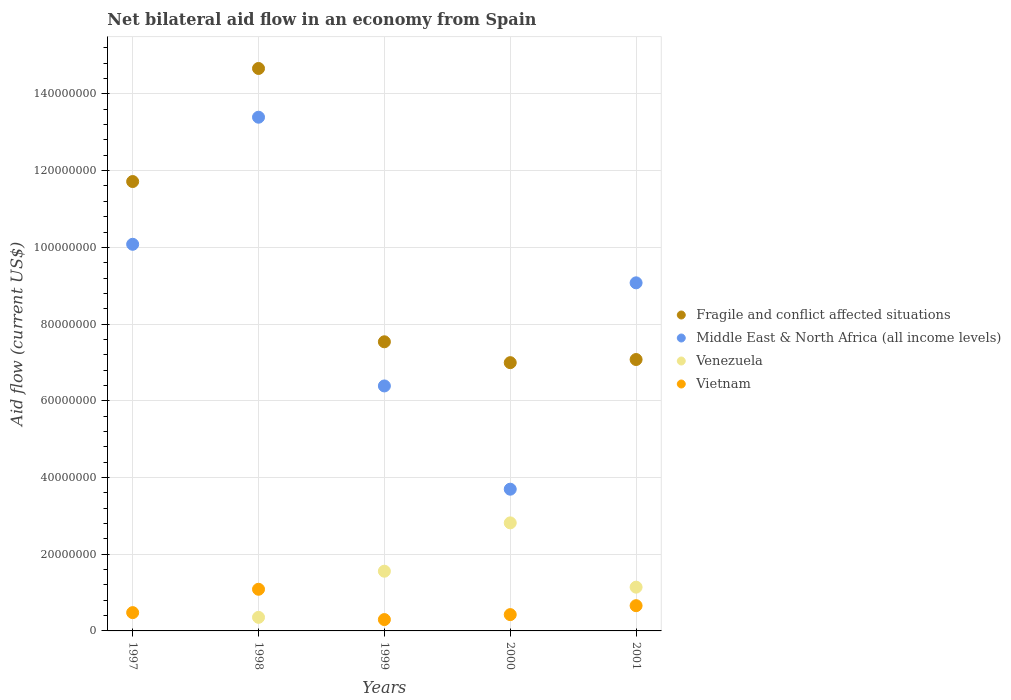How many different coloured dotlines are there?
Offer a very short reply. 4. Is the number of dotlines equal to the number of legend labels?
Provide a short and direct response. No. What is the net bilateral aid flow in Middle East & North Africa (all income levels) in 2000?
Your answer should be very brief. 3.70e+07. Across all years, what is the maximum net bilateral aid flow in Fragile and conflict affected situations?
Your answer should be compact. 1.47e+08. What is the total net bilateral aid flow in Middle East & North Africa (all income levels) in the graph?
Give a very brief answer. 4.26e+08. What is the difference between the net bilateral aid flow in Middle East & North Africa (all income levels) in 1999 and that in 2001?
Your answer should be compact. -2.69e+07. What is the difference between the net bilateral aid flow in Fragile and conflict affected situations in 1998 and the net bilateral aid flow in Vietnam in 2001?
Your answer should be compact. 1.40e+08. What is the average net bilateral aid flow in Vietnam per year?
Give a very brief answer. 5.88e+06. In the year 1999, what is the difference between the net bilateral aid flow in Vietnam and net bilateral aid flow in Fragile and conflict affected situations?
Offer a very short reply. -7.24e+07. What is the ratio of the net bilateral aid flow in Venezuela in 1999 to that in 2001?
Your answer should be compact. 1.36. Is the difference between the net bilateral aid flow in Vietnam in 1998 and 2000 greater than the difference between the net bilateral aid flow in Fragile and conflict affected situations in 1998 and 2000?
Keep it short and to the point. No. What is the difference between the highest and the second highest net bilateral aid flow in Vietnam?
Provide a succinct answer. 4.28e+06. What is the difference between the highest and the lowest net bilateral aid flow in Venezuela?
Your answer should be very brief. 2.82e+07. Is the sum of the net bilateral aid flow in Venezuela in 1999 and 2001 greater than the maximum net bilateral aid flow in Vietnam across all years?
Your response must be concise. Yes. Is the net bilateral aid flow in Venezuela strictly greater than the net bilateral aid flow in Vietnam over the years?
Provide a short and direct response. No. How many dotlines are there?
Provide a short and direct response. 4. How many years are there in the graph?
Make the answer very short. 5. What is the difference between two consecutive major ticks on the Y-axis?
Provide a succinct answer. 2.00e+07. Does the graph contain any zero values?
Make the answer very short. Yes. How many legend labels are there?
Your answer should be compact. 4. How are the legend labels stacked?
Offer a terse response. Vertical. What is the title of the graph?
Offer a very short reply. Net bilateral aid flow in an economy from Spain. What is the label or title of the X-axis?
Keep it short and to the point. Years. What is the label or title of the Y-axis?
Keep it short and to the point. Aid flow (current US$). What is the Aid flow (current US$) of Fragile and conflict affected situations in 1997?
Provide a succinct answer. 1.17e+08. What is the Aid flow (current US$) in Middle East & North Africa (all income levels) in 1997?
Your response must be concise. 1.01e+08. What is the Aid flow (current US$) of Venezuela in 1997?
Give a very brief answer. 0. What is the Aid flow (current US$) in Vietnam in 1997?
Provide a short and direct response. 4.77e+06. What is the Aid flow (current US$) in Fragile and conflict affected situations in 1998?
Provide a succinct answer. 1.47e+08. What is the Aid flow (current US$) in Middle East & North Africa (all income levels) in 1998?
Your answer should be compact. 1.34e+08. What is the Aid flow (current US$) of Venezuela in 1998?
Offer a very short reply. 3.54e+06. What is the Aid flow (current US$) of Vietnam in 1998?
Your answer should be compact. 1.09e+07. What is the Aid flow (current US$) in Fragile and conflict affected situations in 1999?
Your answer should be very brief. 7.54e+07. What is the Aid flow (current US$) in Middle East & North Africa (all income levels) in 1999?
Make the answer very short. 6.39e+07. What is the Aid flow (current US$) of Venezuela in 1999?
Give a very brief answer. 1.56e+07. What is the Aid flow (current US$) of Vietnam in 1999?
Offer a terse response. 2.96e+06. What is the Aid flow (current US$) of Fragile and conflict affected situations in 2000?
Offer a very short reply. 6.99e+07. What is the Aid flow (current US$) of Middle East & North Africa (all income levels) in 2000?
Ensure brevity in your answer.  3.70e+07. What is the Aid flow (current US$) of Venezuela in 2000?
Provide a short and direct response. 2.82e+07. What is the Aid flow (current US$) in Vietnam in 2000?
Give a very brief answer. 4.25e+06. What is the Aid flow (current US$) of Fragile and conflict affected situations in 2001?
Your answer should be very brief. 7.08e+07. What is the Aid flow (current US$) in Middle East & North Africa (all income levels) in 2001?
Your answer should be very brief. 9.08e+07. What is the Aid flow (current US$) of Venezuela in 2001?
Ensure brevity in your answer.  1.14e+07. What is the Aid flow (current US$) in Vietnam in 2001?
Your response must be concise. 6.58e+06. Across all years, what is the maximum Aid flow (current US$) of Fragile and conflict affected situations?
Keep it short and to the point. 1.47e+08. Across all years, what is the maximum Aid flow (current US$) of Middle East & North Africa (all income levels)?
Make the answer very short. 1.34e+08. Across all years, what is the maximum Aid flow (current US$) in Venezuela?
Ensure brevity in your answer.  2.82e+07. Across all years, what is the maximum Aid flow (current US$) of Vietnam?
Give a very brief answer. 1.09e+07. Across all years, what is the minimum Aid flow (current US$) in Fragile and conflict affected situations?
Provide a succinct answer. 6.99e+07. Across all years, what is the minimum Aid flow (current US$) in Middle East & North Africa (all income levels)?
Your response must be concise. 3.70e+07. Across all years, what is the minimum Aid flow (current US$) in Venezuela?
Ensure brevity in your answer.  0. Across all years, what is the minimum Aid flow (current US$) in Vietnam?
Offer a terse response. 2.96e+06. What is the total Aid flow (current US$) in Fragile and conflict affected situations in the graph?
Your response must be concise. 4.80e+08. What is the total Aid flow (current US$) of Middle East & North Africa (all income levels) in the graph?
Your response must be concise. 4.26e+08. What is the total Aid flow (current US$) of Venezuela in the graph?
Ensure brevity in your answer.  5.87e+07. What is the total Aid flow (current US$) of Vietnam in the graph?
Provide a short and direct response. 2.94e+07. What is the difference between the Aid flow (current US$) of Fragile and conflict affected situations in 1997 and that in 1998?
Provide a short and direct response. -2.95e+07. What is the difference between the Aid flow (current US$) of Middle East & North Africa (all income levels) in 1997 and that in 1998?
Offer a very short reply. -3.31e+07. What is the difference between the Aid flow (current US$) of Vietnam in 1997 and that in 1998?
Your answer should be compact. -6.09e+06. What is the difference between the Aid flow (current US$) of Fragile and conflict affected situations in 1997 and that in 1999?
Offer a very short reply. 4.18e+07. What is the difference between the Aid flow (current US$) in Middle East & North Africa (all income levels) in 1997 and that in 1999?
Provide a short and direct response. 3.69e+07. What is the difference between the Aid flow (current US$) of Vietnam in 1997 and that in 1999?
Offer a very short reply. 1.81e+06. What is the difference between the Aid flow (current US$) in Fragile and conflict affected situations in 1997 and that in 2000?
Your answer should be very brief. 4.72e+07. What is the difference between the Aid flow (current US$) in Middle East & North Africa (all income levels) in 1997 and that in 2000?
Provide a succinct answer. 6.38e+07. What is the difference between the Aid flow (current US$) in Vietnam in 1997 and that in 2000?
Provide a short and direct response. 5.20e+05. What is the difference between the Aid flow (current US$) of Fragile and conflict affected situations in 1997 and that in 2001?
Offer a very short reply. 4.64e+07. What is the difference between the Aid flow (current US$) of Middle East & North Africa (all income levels) in 1997 and that in 2001?
Your answer should be compact. 1.00e+07. What is the difference between the Aid flow (current US$) in Vietnam in 1997 and that in 2001?
Offer a very short reply. -1.81e+06. What is the difference between the Aid flow (current US$) in Fragile and conflict affected situations in 1998 and that in 1999?
Your response must be concise. 7.13e+07. What is the difference between the Aid flow (current US$) of Middle East & North Africa (all income levels) in 1998 and that in 1999?
Your response must be concise. 7.01e+07. What is the difference between the Aid flow (current US$) in Venezuela in 1998 and that in 1999?
Keep it short and to the point. -1.20e+07. What is the difference between the Aid flow (current US$) of Vietnam in 1998 and that in 1999?
Your response must be concise. 7.90e+06. What is the difference between the Aid flow (current US$) of Fragile and conflict affected situations in 1998 and that in 2000?
Keep it short and to the point. 7.67e+07. What is the difference between the Aid flow (current US$) of Middle East & North Africa (all income levels) in 1998 and that in 2000?
Provide a short and direct response. 9.70e+07. What is the difference between the Aid flow (current US$) in Venezuela in 1998 and that in 2000?
Keep it short and to the point. -2.46e+07. What is the difference between the Aid flow (current US$) of Vietnam in 1998 and that in 2000?
Ensure brevity in your answer.  6.61e+06. What is the difference between the Aid flow (current US$) of Fragile and conflict affected situations in 1998 and that in 2001?
Offer a very short reply. 7.59e+07. What is the difference between the Aid flow (current US$) of Middle East & North Africa (all income levels) in 1998 and that in 2001?
Keep it short and to the point. 4.32e+07. What is the difference between the Aid flow (current US$) in Venezuela in 1998 and that in 2001?
Offer a terse response. -7.87e+06. What is the difference between the Aid flow (current US$) in Vietnam in 1998 and that in 2001?
Give a very brief answer. 4.28e+06. What is the difference between the Aid flow (current US$) in Fragile and conflict affected situations in 1999 and that in 2000?
Offer a very short reply. 5.44e+06. What is the difference between the Aid flow (current US$) of Middle East & North Africa (all income levels) in 1999 and that in 2000?
Your answer should be compact. 2.69e+07. What is the difference between the Aid flow (current US$) of Venezuela in 1999 and that in 2000?
Offer a terse response. -1.26e+07. What is the difference between the Aid flow (current US$) in Vietnam in 1999 and that in 2000?
Offer a very short reply. -1.29e+06. What is the difference between the Aid flow (current US$) in Fragile and conflict affected situations in 1999 and that in 2001?
Offer a very short reply. 4.62e+06. What is the difference between the Aid flow (current US$) of Middle East & North Africa (all income levels) in 1999 and that in 2001?
Provide a succinct answer. -2.69e+07. What is the difference between the Aid flow (current US$) in Venezuela in 1999 and that in 2001?
Your response must be concise. 4.16e+06. What is the difference between the Aid flow (current US$) in Vietnam in 1999 and that in 2001?
Keep it short and to the point. -3.62e+06. What is the difference between the Aid flow (current US$) of Fragile and conflict affected situations in 2000 and that in 2001?
Offer a terse response. -8.20e+05. What is the difference between the Aid flow (current US$) in Middle East & North Africa (all income levels) in 2000 and that in 2001?
Ensure brevity in your answer.  -5.38e+07. What is the difference between the Aid flow (current US$) in Venezuela in 2000 and that in 2001?
Your answer should be compact. 1.68e+07. What is the difference between the Aid flow (current US$) in Vietnam in 2000 and that in 2001?
Your answer should be very brief. -2.33e+06. What is the difference between the Aid flow (current US$) of Fragile and conflict affected situations in 1997 and the Aid flow (current US$) of Middle East & North Africa (all income levels) in 1998?
Your response must be concise. -1.68e+07. What is the difference between the Aid flow (current US$) of Fragile and conflict affected situations in 1997 and the Aid flow (current US$) of Venezuela in 1998?
Provide a succinct answer. 1.14e+08. What is the difference between the Aid flow (current US$) of Fragile and conflict affected situations in 1997 and the Aid flow (current US$) of Vietnam in 1998?
Make the answer very short. 1.06e+08. What is the difference between the Aid flow (current US$) of Middle East & North Africa (all income levels) in 1997 and the Aid flow (current US$) of Venezuela in 1998?
Offer a terse response. 9.73e+07. What is the difference between the Aid flow (current US$) of Middle East & North Africa (all income levels) in 1997 and the Aid flow (current US$) of Vietnam in 1998?
Provide a short and direct response. 8.99e+07. What is the difference between the Aid flow (current US$) of Fragile and conflict affected situations in 1997 and the Aid flow (current US$) of Middle East & North Africa (all income levels) in 1999?
Offer a terse response. 5.33e+07. What is the difference between the Aid flow (current US$) in Fragile and conflict affected situations in 1997 and the Aid flow (current US$) in Venezuela in 1999?
Give a very brief answer. 1.02e+08. What is the difference between the Aid flow (current US$) of Fragile and conflict affected situations in 1997 and the Aid flow (current US$) of Vietnam in 1999?
Your answer should be very brief. 1.14e+08. What is the difference between the Aid flow (current US$) in Middle East & North Africa (all income levels) in 1997 and the Aid flow (current US$) in Venezuela in 1999?
Make the answer very short. 8.52e+07. What is the difference between the Aid flow (current US$) in Middle East & North Africa (all income levels) in 1997 and the Aid flow (current US$) in Vietnam in 1999?
Offer a terse response. 9.78e+07. What is the difference between the Aid flow (current US$) of Fragile and conflict affected situations in 1997 and the Aid flow (current US$) of Middle East & North Africa (all income levels) in 2000?
Give a very brief answer. 8.02e+07. What is the difference between the Aid flow (current US$) in Fragile and conflict affected situations in 1997 and the Aid flow (current US$) in Venezuela in 2000?
Keep it short and to the point. 8.90e+07. What is the difference between the Aid flow (current US$) in Fragile and conflict affected situations in 1997 and the Aid flow (current US$) in Vietnam in 2000?
Your response must be concise. 1.13e+08. What is the difference between the Aid flow (current US$) in Middle East & North Africa (all income levels) in 1997 and the Aid flow (current US$) in Venezuela in 2000?
Offer a terse response. 7.26e+07. What is the difference between the Aid flow (current US$) in Middle East & North Africa (all income levels) in 1997 and the Aid flow (current US$) in Vietnam in 2000?
Ensure brevity in your answer.  9.66e+07. What is the difference between the Aid flow (current US$) in Fragile and conflict affected situations in 1997 and the Aid flow (current US$) in Middle East & North Africa (all income levels) in 2001?
Your answer should be compact. 2.64e+07. What is the difference between the Aid flow (current US$) in Fragile and conflict affected situations in 1997 and the Aid flow (current US$) in Venezuela in 2001?
Offer a terse response. 1.06e+08. What is the difference between the Aid flow (current US$) of Fragile and conflict affected situations in 1997 and the Aid flow (current US$) of Vietnam in 2001?
Your answer should be compact. 1.11e+08. What is the difference between the Aid flow (current US$) in Middle East & North Africa (all income levels) in 1997 and the Aid flow (current US$) in Venezuela in 2001?
Offer a terse response. 8.94e+07. What is the difference between the Aid flow (current US$) in Middle East & North Africa (all income levels) in 1997 and the Aid flow (current US$) in Vietnam in 2001?
Offer a terse response. 9.42e+07. What is the difference between the Aid flow (current US$) of Fragile and conflict affected situations in 1998 and the Aid flow (current US$) of Middle East & North Africa (all income levels) in 1999?
Give a very brief answer. 8.28e+07. What is the difference between the Aid flow (current US$) of Fragile and conflict affected situations in 1998 and the Aid flow (current US$) of Venezuela in 1999?
Provide a short and direct response. 1.31e+08. What is the difference between the Aid flow (current US$) of Fragile and conflict affected situations in 1998 and the Aid flow (current US$) of Vietnam in 1999?
Offer a very short reply. 1.44e+08. What is the difference between the Aid flow (current US$) in Middle East & North Africa (all income levels) in 1998 and the Aid flow (current US$) in Venezuela in 1999?
Your answer should be compact. 1.18e+08. What is the difference between the Aid flow (current US$) of Middle East & North Africa (all income levels) in 1998 and the Aid flow (current US$) of Vietnam in 1999?
Ensure brevity in your answer.  1.31e+08. What is the difference between the Aid flow (current US$) of Venezuela in 1998 and the Aid flow (current US$) of Vietnam in 1999?
Provide a short and direct response. 5.80e+05. What is the difference between the Aid flow (current US$) in Fragile and conflict affected situations in 1998 and the Aid flow (current US$) in Middle East & North Africa (all income levels) in 2000?
Offer a terse response. 1.10e+08. What is the difference between the Aid flow (current US$) of Fragile and conflict affected situations in 1998 and the Aid flow (current US$) of Venezuela in 2000?
Your answer should be compact. 1.18e+08. What is the difference between the Aid flow (current US$) in Fragile and conflict affected situations in 1998 and the Aid flow (current US$) in Vietnam in 2000?
Offer a very short reply. 1.42e+08. What is the difference between the Aid flow (current US$) in Middle East & North Africa (all income levels) in 1998 and the Aid flow (current US$) in Venezuela in 2000?
Ensure brevity in your answer.  1.06e+08. What is the difference between the Aid flow (current US$) in Middle East & North Africa (all income levels) in 1998 and the Aid flow (current US$) in Vietnam in 2000?
Your response must be concise. 1.30e+08. What is the difference between the Aid flow (current US$) in Venezuela in 1998 and the Aid flow (current US$) in Vietnam in 2000?
Your answer should be compact. -7.10e+05. What is the difference between the Aid flow (current US$) of Fragile and conflict affected situations in 1998 and the Aid flow (current US$) of Middle East & North Africa (all income levels) in 2001?
Offer a very short reply. 5.59e+07. What is the difference between the Aid flow (current US$) in Fragile and conflict affected situations in 1998 and the Aid flow (current US$) in Venezuela in 2001?
Give a very brief answer. 1.35e+08. What is the difference between the Aid flow (current US$) of Fragile and conflict affected situations in 1998 and the Aid flow (current US$) of Vietnam in 2001?
Your response must be concise. 1.40e+08. What is the difference between the Aid flow (current US$) of Middle East & North Africa (all income levels) in 1998 and the Aid flow (current US$) of Venezuela in 2001?
Offer a terse response. 1.23e+08. What is the difference between the Aid flow (current US$) of Middle East & North Africa (all income levels) in 1998 and the Aid flow (current US$) of Vietnam in 2001?
Keep it short and to the point. 1.27e+08. What is the difference between the Aid flow (current US$) of Venezuela in 1998 and the Aid flow (current US$) of Vietnam in 2001?
Your answer should be very brief. -3.04e+06. What is the difference between the Aid flow (current US$) of Fragile and conflict affected situations in 1999 and the Aid flow (current US$) of Middle East & North Africa (all income levels) in 2000?
Your answer should be compact. 3.84e+07. What is the difference between the Aid flow (current US$) of Fragile and conflict affected situations in 1999 and the Aid flow (current US$) of Venezuela in 2000?
Make the answer very short. 4.72e+07. What is the difference between the Aid flow (current US$) in Fragile and conflict affected situations in 1999 and the Aid flow (current US$) in Vietnam in 2000?
Give a very brief answer. 7.11e+07. What is the difference between the Aid flow (current US$) in Middle East & North Africa (all income levels) in 1999 and the Aid flow (current US$) in Venezuela in 2000?
Give a very brief answer. 3.57e+07. What is the difference between the Aid flow (current US$) of Middle East & North Africa (all income levels) in 1999 and the Aid flow (current US$) of Vietnam in 2000?
Offer a terse response. 5.96e+07. What is the difference between the Aid flow (current US$) in Venezuela in 1999 and the Aid flow (current US$) in Vietnam in 2000?
Keep it short and to the point. 1.13e+07. What is the difference between the Aid flow (current US$) in Fragile and conflict affected situations in 1999 and the Aid flow (current US$) in Middle East & North Africa (all income levels) in 2001?
Provide a short and direct response. -1.54e+07. What is the difference between the Aid flow (current US$) in Fragile and conflict affected situations in 1999 and the Aid flow (current US$) in Venezuela in 2001?
Your response must be concise. 6.40e+07. What is the difference between the Aid flow (current US$) in Fragile and conflict affected situations in 1999 and the Aid flow (current US$) in Vietnam in 2001?
Your answer should be compact. 6.88e+07. What is the difference between the Aid flow (current US$) in Middle East & North Africa (all income levels) in 1999 and the Aid flow (current US$) in Venezuela in 2001?
Keep it short and to the point. 5.25e+07. What is the difference between the Aid flow (current US$) of Middle East & North Africa (all income levels) in 1999 and the Aid flow (current US$) of Vietnam in 2001?
Offer a terse response. 5.73e+07. What is the difference between the Aid flow (current US$) of Venezuela in 1999 and the Aid flow (current US$) of Vietnam in 2001?
Your answer should be very brief. 8.99e+06. What is the difference between the Aid flow (current US$) in Fragile and conflict affected situations in 2000 and the Aid flow (current US$) in Middle East & North Africa (all income levels) in 2001?
Your answer should be compact. -2.08e+07. What is the difference between the Aid flow (current US$) in Fragile and conflict affected situations in 2000 and the Aid flow (current US$) in Venezuela in 2001?
Offer a very short reply. 5.85e+07. What is the difference between the Aid flow (current US$) in Fragile and conflict affected situations in 2000 and the Aid flow (current US$) in Vietnam in 2001?
Provide a short and direct response. 6.34e+07. What is the difference between the Aid flow (current US$) in Middle East & North Africa (all income levels) in 2000 and the Aid flow (current US$) in Venezuela in 2001?
Offer a terse response. 2.55e+07. What is the difference between the Aid flow (current US$) of Middle East & North Africa (all income levels) in 2000 and the Aid flow (current US$) of Vietnam in 2001?
Your response must be concise. 3.04e+07. What is the difference between the Aid flow (current US$) of Venezuela in 2000 and the Aid flow (current US$) of Vietnam in 2001?
Provide a succinct answer. 2.16e+07. What is the average Aid flow (current US$) of Fragile and conflict affected situations per year?
Your response must be concise. 9.60e+07. What is the average Aid flow (current US$) of Middle East & North Africa (all income levels) per year?
Provide a short and direct response. 8.53e+07. What is the average Aid flow (current US$) of Venezuela per year?
Offer a very short reply. 1.17e+07. What is the average Aid flow (current US$) in Vietnam per year?
Offer a terse response. 5.88e+06. In the year 1997, what is the difference between the Aid flow (current US$) in Fragile and conflict affected situations and Aid flow (current US$) in Middle East & North Africa (all income levels)?
Your answer should be compact. 1.64e+07. In the year 1997, what is the difference between the Aid flow (current US$) of Fragile and conflict affected situations and Aid flow (current US$) of Vietnam?
Provide a short and direct response. 1.12e+08. In the year 1997, what is the difference between the Aid flow (current US$) in Middle East & North Africa (all income levels) and Aid flow (current US$) in Vietnam?
Provide a succinct answer. 9.60e+07. In the year 1998, what is the difference between the Aid flow (current US$) in Fragile and conflict affected situations and Aid flow (current US$) in Middle East & North Africa (all income levels)?
Give a very brief answer. 1.27e+07. In the year 1998, what is the difference between the Aid flow (current US$) in Fragile and conflict affected situations and Aid flow (current US$) in Venezuela?
Provide a short and direct response. 1.43e+08. In the year 1998, what is the difference between the Aid flow (current US$) of Fragile and conflict affected situations and Aid flow (current US$) of Vietnam?
Keep it short and to the point. 1.36e+08. In the year 1998, what is the difference between the Aid flow (current US$) in Middle East & North Africa (all income levels) and Aid flow (current US$) in Venezuela?
Keep it short and to the point. 1.30e+08. In the year 1998, what is the difference between the Aid flow (current US$) of Middle East & North Africa (all income levels) and Aid flow (current US$) of Vietnam?
Provide a succinct answer. 1.23e+08. In the year 1998, what is the difference between the Aid flow (current US$) in Venezuela and Aid flow (current US$) in Vietnam?
Your response must be concise. -7.32e+06. In the year 1999, what is the difference between the Aid flow (current US$) of Fragile and conflict affected situations and Aid flow (current US$) of Middle East & North Africa (all income levels)?
Provide a succinct answer. 1.15e+07. In the year 1999, what is the difference between the Aid flow (current US$) in Fragile and conflict affected situations and Aid flow (current US$) in Venezuela?
Provide a short and direct response. 5.98e+07. In the year 1999, what is the difference between the Aid flow (current US$) in Fragile and conflict affected situations and Aid flow (current US$) in Vietnam?
Provide a short and direct response. 7.24e+07. In the year 1999, what is the difference between the Aid flow (current US$) in Middle East & North Africa (all income levels) and Aid flow (current US$) in Venezuela?
Keep it short and to the point. 4.83e+07. In the year 1999, what is the difference between the Aid flow (current US$) in Middle East & North Africa (all income levels) and Aid flow (current US$) in Vietnam?
Offer a terse response. 6.09e+07. In the year 1999, what is the difference between the Aid flow (current US$) of Venezuela and Aid flow (current US$) of Vietnam?
Make the answer very short. 1.26e+07. In the year 2000, what is the difference between the Aid flow (current US$) of Fragile and conflict affected situations and Aid flow (current US$) of Middle East & North Africa (all income levels)?
Ensure brevity in your answer.  3.30e+07. In the year 2000, what is the difference between the Aid flow (current US$) of Fragile and conflict affected situations and Aid flow (current US$) of Venezuela?
Ensure brevity in your answer.  4.18e+07. In the year 2000, what is the difference between the Aid flow (current US$) in Fragile and conflict affected situations and Aid flow (current US$) in Vietnam?
Offer a terse response. 6.57e+07. In the year 2000, what is the difference between the Aid flow (current US$) in Middle East & North Africa (all income levels) and Aid flow (current US$) in Venezuela?
Make the answer very short. 8.78e+06. In the year 2000, what is the difference between the Aid flow (current US$) of Middle East & North Africa (all income levels) and Aid flow (current US$) of Vietnam?
Ensure brevity in your answer.  3.27e+07. In the year 2000, what is the difference between the Aid flow (current US$) of Venezuela and Aid flow (current US$) of Vietnam?
Ensure brevity in your answer.  2.39e+07. In the year 2001, what is the difference between the Aid flow (current US$) in Fragile and conflict affected situations and Aid flow (current US$) in Middle East & North Africa (all income levels)?
Your response must be concise. -2.00e+07. In the year 2001, what is the difference between the Aid flow (current US$) of Fragile and conflict affected situations and Aid flow (current US$) of Venezuela?
Provide a succinct answer. 5.94e+07. In the year 2001, what is the difference between the Aid flow (current US$) in Fragile and conflict affected situations and Aid flow (current US$) in Vietnam?
Keep it short and to the point. 6.42e+07. In the year 2001, what is the difference between the Aid flow (current US$) of Middle East & North Africa (all income levels) and Aid flow (current US$) of Venezuela?
Give a very brief answer. 7.93e+07. In the year 2001, what is the difference between the Aid flow (current US$) in Middle East & North Africa (all income levels) and Aid flow (current US$) in Vietnam?
Your answer should be compact. 8.42e+07. In the year 2001, what is the difference between the Aid flow (current US$) in Venezuela and Aid flow (current US$) in Vietnam?
Your response must be concise. 4.83e+06. What is the ratio of the Aid flow (current US$) in Fragile and conflict affected situations in 1997 to that in 1998?
Provide a short and direct response. 0.8. What is the ratio of the Aid flow (current US$) in Middle East & North Africa (all income levels) in 1997 to that in 1998?
Your answer should be compact. 0.75. What is the ratio of the Aid flow (current US$) in Vietnam in 1997 to that in 1998?
Offer a very short reply. 0.44. What is the ratio of the Aid flow (current US$) in Fragile and conflict affected situations in 1997 to that in 1999?
Offer a terse response. 1.55. What is the ratio of the Aid flow (current US$) of Middle East & North Africa (all income levels) in 1997 to that in 1999?
Ensure brevity in your answer.  1.58. What is the ratio of the Aid flow (current US$) of Vietnam in 1997 to that in 1999?
Your answer should be very brief. 1.61. What is the ratio of the Aid flow (current US$) in Fragile and conflict affected situations in 1997 to that in 2000?
Give a very brief answer. 1.68. What is the ratio of the Aid flow (current US$) in Middle East & North Africa (all income levels) in 1997 to that in 2000?
Offer a terse response. 2.73. What is the ratio of the Aid flow (current US$) in Vietnam in 1997 to that in 2000?
Offer a very short reply. 1.12. What is the ratio of the Aid flow (current US$) of Fragile and conflict affected situations in 1997 to that in 2001?
Offer a very short reply. 1.66. What is the ratio of the Aid flow (current US$) in Middle East & North Africa (all income levels) in 1997 to that in 2001?
Your answer should be compact. 1.11. What is the ratio of the Aid flow (current US$) in Vietnam in 1997 to that in 2001?
Keep it short and to the point. 0.72. What is the ratio of the Aid flow (current US$) in Fragile and conflict affected situations in 1998 to that in 1999?
Offer a very short reply. 1.95. What is the ratio of the Aid flow (current US$) in Middle East & North Africa (all income levels) in 1998 to that in 1999?
Offer a terse response. 2.1. What is the ratio of the Aid flow (current US$) in Venezuela in 1998 to that in 1999?
Offer a very short reply. 0.23. What is the ratio of the Aid flow (current US$) in Vietnam in 1998 to that in 1999?
Your answer should be very brief. 3.67. What is the ratio of the Aid flow (current US$) of Fragile and conflict affected situations in 1998 to that in 2000?
Your response must be concise. 2.1. What is the ratio of the Aid flow (current US$) in Middle East & North Africa (all income levels) in 1998 to that in 2000?
Give a very brief answer. 3.62. What is the ratio of the Aid flow (current US$) in Venezuela in 1998 to that in 2000?
Provide a succinct answer. 0.13. What is the ratio of the Aid flow (current US$) of Vietnam in 1998 to that in 2000?
Ensure brevity in your answer.  2.56. What is the ratio of the Aid flow (current US$) in Fragile and conflict affected situations in 1998 to that in 2001?
Offer a terse response. 2.07. What is the ratio of the Aid flow (current US$) in Middle East & North Africa (all income levels) in 1998 to that in 2001?
Give a very brief answer. 1.48. What is the ratio of the Aid flow (current US$) of Venezuela in 1998 to that in 2001?
Provide a succinct answer. 0.31. What is the ratio of the Aid flow (current US$) of Vietnam in 1998 to that in 2001?
Give a very brief answer. 1.65. What is the ratio of the Aid flow (current US$) of Fragile and conflict affected situations in 1999 to that in 2000?
Provide a short and direct response. 1.08. What is the ratio of the Aid flow (current US$) in Middle East & North Africa (all income levels) in 1999 to that in 2000?
Provide a succinct answer. 1.73. What is the ratio of the Aid flow (current US$) of Venezuela in 1999 to that in 2000?
Your response must be concise. 0.55. What is the ratio of the Aid flow (current US$) in Vietnam in 1999 to that in 2000?
Provide a succinct answer. 0.7. What is the ratio of the Aid flow (current US$) in Fragile and conflict affected situations in 1999 to that in 2001?
Give a very brief answer. 1.07. What is the ratio of the Aid flow (current US$) of Middle East & North Africa (all income levels) in 1999 to that in 2001?
Provide a short and direct response. 0.7. What is the ratio of the Aid flow (current US$) of Venezuela in 1999 to that in 2001?
Provide a succinct answer. 1.36. What is the ratio of the Aid flow (current US$) in Vietnam in 1999 to that in 2001?
Give a very brief answer. 0.45. What is the ratio of the Aid flow (current US$) in Fragile and conflict affected situations in 2000 to that in 2001?
Offer a terse response. 0.99. What is the ratio of the Aid flow (current US$) of Middle East & North Africa (all income levels) in 2000 to that in 2001?
Keep it short and to the point. 0.41. What is the ratio of the Aid flow (current US$) of Venezuela in 2000 to that in 2001?
Provide a succinct answer. 2.47. What is the ratio of the Aid flow (current US$) of Vietnam in 2000 to that in 2001?
Provide a succinct answer. 0.65. What is the difference between the highest and the second highest Aid flow (current US$) of Fragile and conflict affected situations?
Your answer should be very brief. 2.95e+07. What is the difference between the highest and the second highest Aid flow (current US$) of Middle East & North Africa (all income levels)?
Your response must be concise. 3.31e+07. What is the difference between the highest and the second highest Aid flow (current US$) in Venezuela?
Ensure brevity in your answer.  1.26e+07. What is the difference between the highest and the second highest Aid flow (current US$) in Vietnam?
Give a very brief answer. 4.28e+06. What is the difference between the highest and the lowest Aid flow (current US$) in Fragile and conflict affected situations?
Provide a succinct answer. 7.67e+07. What is the difference between the highest and the lowest Aid flow (current US$) in Middle East & North Africa (all income levels)?
Offer a terse response. 9.70e+07. What is the difference between the highest and the lowest Aid flow (current US$) in Venezuela?
Your answer should be compact. 2.82e+07. What is the difference between the highest and the lowest Aid flow (current US$) in Vietnam?
Your response must be concise. 7.90e+06. 